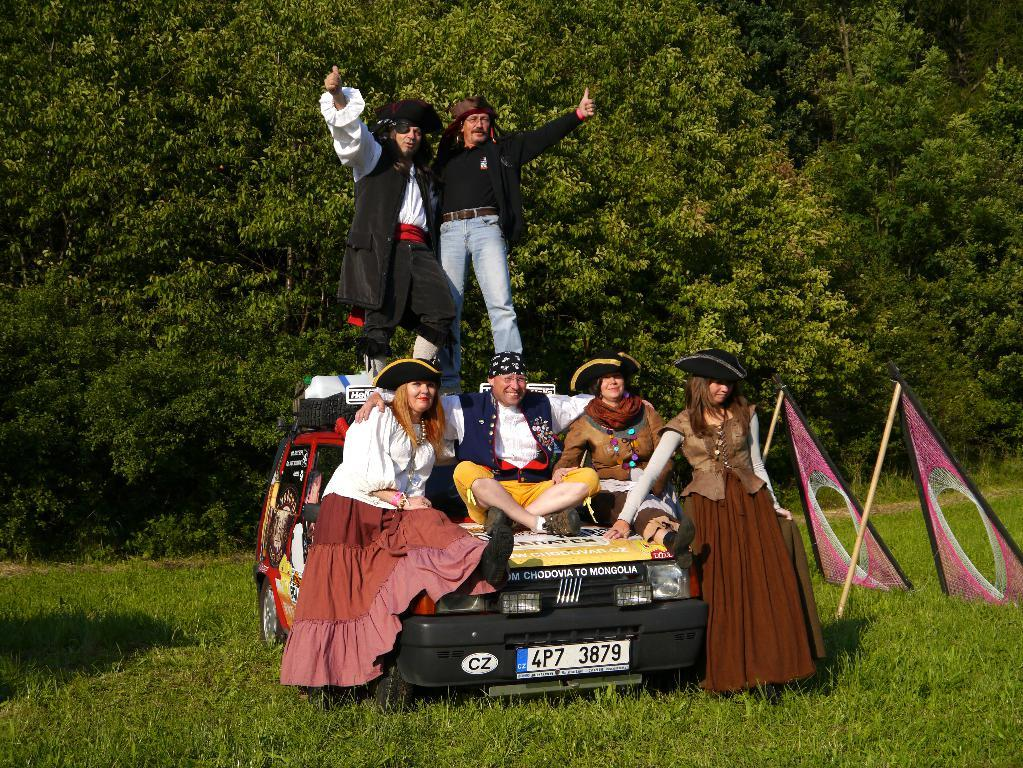What are the people doing in the image? The people are on a car. Where is the car located? The car is placed on the grass. What can be seen in the background of the image? There are trees visible in the background. What type of scarf is the person wearing while jumping in the image? There is no person wearing a scarf or jumping in the image; the people are on a car that is placed on the grass. 